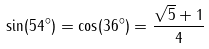Convert formula to latex. <formula><loc_0><loc_0><loc_500><loc_500>\sin ( 5 4 ^ { \circ } ) = \cos ( 3 6 ^ { \circ } ) = { \frac { { \sqrt { 5 } } + 1 } { 4 } }</formula> 